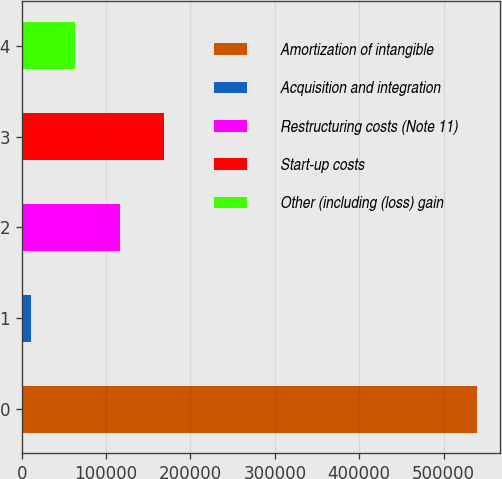Convert chart to OTSL. <chart><loc_0><loc_0><loc_500><loc_500><bar_chart><fcel>Amortization of intangible<fcel>Acquisition and integration<fcel>Restructuring costs (Note 11)<fcel>Start-up costs<fcel>Other (including (loss) gain<nl><fcel>539362<fcel>10561<fcel>116321<fcel>169201<fcel>63441.1<nl></chart> 